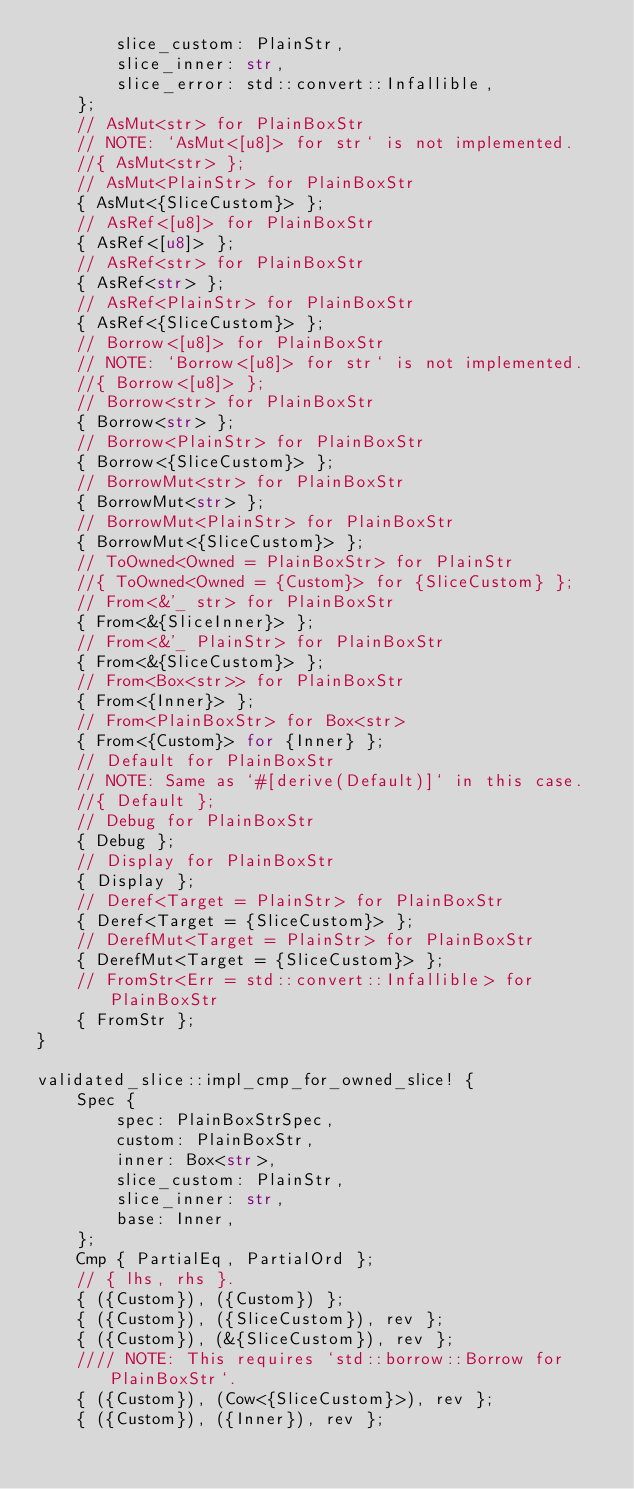Convert code to text. <code><loc_0><loc_0><loc_500><loc_500><_Rust_>        slice_custom: PlainStr,
        slice_inner: str,
        slice_error: std::convert::Infallible,
    };
    // AsMut<str> for PlainBoxStr
    // NOTE: `AsMut<[u8]> for str` is not implemented.
    //{ AsMut<str> };
    // AsMut<PlainStr> for PlainBoxStr
    { AsMut<{SliceCustom}> };
    // AsRef<[u8]> for PlainBoxStr
    { AsRef<[u8]> };
    // AsRef<str> for PlainBoxStr
    { AsRef<str> };
    // AsRef<PlainStr> for PlainBoxStr
    { AsRef<{SliceCustom}> };
    // Borrow<[u8]> for PlainBoxStr
    // NOTE: `Borrow<[u8]> for str` is not implemented.
    //{ Borrow<[u8]> };
    // Borrow<str> for PlainBoxStr
    { Borrow<str> };
    // Borrow<PlainStr> for PlainBoxStr
    { Borrow<{SliceCustom}> };
    // BorrowMut<str> for PlainBoxStr
    { BorrowMut<str> };
    // BorrowMut<PlainStr> for PlainBoxStr
    { BorrowMut<{SliceCustom}> };
    // ToOwned<Owned = PlainBoxStr> for PlainStr
    //{ ToOwned<Owned = {Custom}> for {SliceCustom} };
    // From<&'_ str> for PlainBoxStr
    { From<&{SliceInner}> };
    // From<&'_ PlainStr> for PlainBoxStr
    { From<&{SliceCustom}> };
    // From<Box<str>> for PlainBoxStr
    { From<{Inner}> };
    // From<PlainBoxStr> for Box<str>
    { From<{Custom}> for {Inner} };
    // Default for PlainBoxStr
    // NOTE: Same as `#[derive(Default)]` in this case.
    //{ Default };
    // Debug for PlainBoxStr
    { Debug };
    // Display for PlainBoxStr
    { Display };
    // Deref<Target = PlainStr> for PlainBoxStr
    { Deref<Target = {SliceCustom}> };
    // DerefMut<Target = PlainStr> for PlainBoxStr
    { DerefMut<Target = {SliceCustom}> };
    // FromStr<Err = std::convert::Infallible> for PlainBoxStr
    { FromStr };
}

validated_slice::impl_cmp_for_owned_slice! {
    Spec {
        spec: PlainBoxStrSpec,
        custom: PlainBoxStr,
        inner: Box<str>,
        slice_custom: PlainStr,
        slice_inner: str,
        base: Inner,
    };
    Cmp { PartialEq, PartialOrd };
    // { lhs, rhs }.
    { ({Custom}), ({Custom}) };
    { ({Custom}), ({SliceCustom}), rev };
    { ({Custom}), (&{SliceCustom}), rev };
    //// NOTE: This requires `std::borrow::Borrow for PlainBoxStr`.
    { ({Custom}), (Cow<{SliceCustom}>), rev };
    { ({Custom}), ({Inner}), rev };</code> 